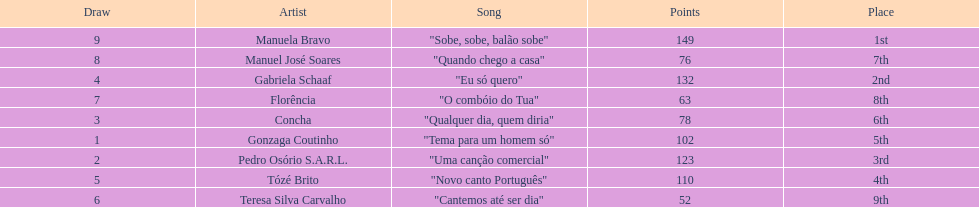Who was the last draw? Manuela Bravo. 